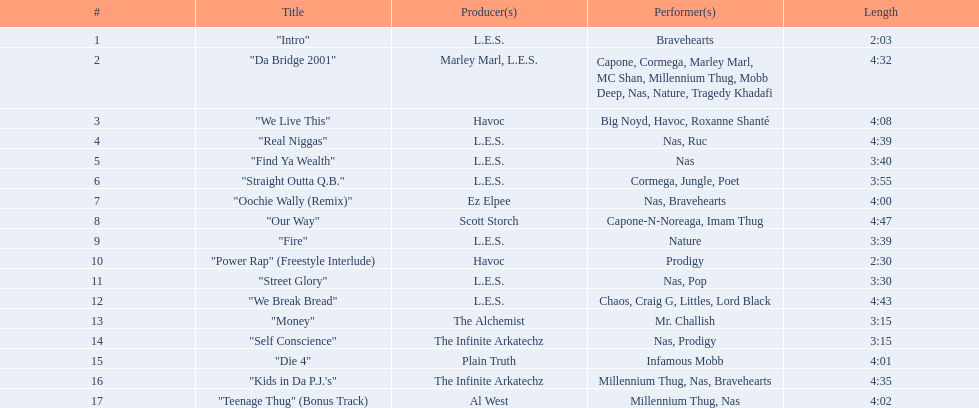What is the length of every song? 2:03, 4:32, 4:08, 4:39, 3:40, 3:55, 4:00, 4:47, 3:39, 2:30, 3:30, 4:43, 3:15, 3:15, 4:01, 4:35, 4:02. Which one is the longest? 4:47. Can you give me this table in json format? {'header': ['#', 'Title', 'Producer(s)', 'Performer(s)', 'Length'], 'rows': [['1', '"Intro"', 'L.E.S.', 'Bravehearts', '2:03'], ['2', '"Da Bridge 2001"', 'Marley Marl, L.E.S.', 'Capone, Cormega, Marley Marl, MC Shan, Millennium Thug, Mobb Deep, Nas, Nature, Tragedy Khadafi', '4:32'], ['3', '"We Live This"', 'Havoc', 'Big Noyd, Havoc, Roxanne Shanté', '4:08'], ['4', '"Real Niggas"', 'L.E.S.', 'Nas, Ruc', '4:39'], ['5', '"Find Ya Wealth"', 'L.E.S.', 'Nas', '3:40'], ['6', '"Straight Outta Q.B."', 'L.E.S.', 'Cormega, Jungle, Poet', '3:55'], ['7', '"Oochie Wally (Remix)"', 'Ez Elpee', 'Nas, Bravehearts', '4:00'], ['8', '"Our Way"', 'Scott Storch', 'Capone-N-Noreaga, Imam Thug', '4:47'], ['9', '"Fire"', 'L.E.S.', 'Nature', '3:39'], ['10', '"Power Rap" (Freestyle Interlude)', 'Havoc', 'Prodigy', '2:30'], ['11', '"Street Glory"', 'L.E.S.', 'Nas, Pop', '3:30'], ['12', '"We Break Bread"', 'L.E.S.', 'Chaos, Craig G, Littles, Lord Black', '4:43'], ['13', '"Money"', 'The Alchemist', 'Mr. Challish', '3:15'], ['14', '"Self Conscience"', 'The Infinite Arkatechz', 'Nas, Prodigy', '3:15'], ['15', '"Die 4"', 'Plain Truth', 'Infamous Mobb', '4:01'], ['16', '"Kids in Da P.J.\'s"', 'The Infinite Arkatechz', 'Millennium Thug, Nas, Bravehearts', '4:35'], ['17', '"Teenage Thug" (Bonus Track)', 'Al West', 'Millennium Thug, Nas', '4:02']]} 